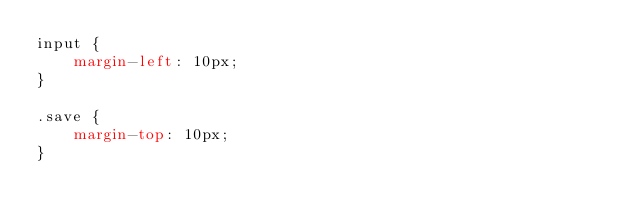Convert code to text. <code><loc_0><loc_0><loc_500><loc_500><_CSS_>input {
    margin-left: 10px;
}

.save {
    margin-top: 10px;
}</code> 